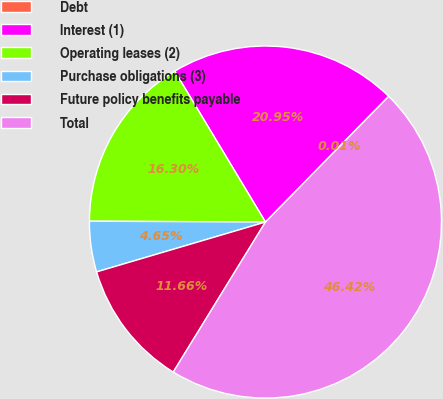Convert chart. <chart><loc_0><loc_0><loc_500><loc_500><pie_chart><fcel>Debt<fcel>Interest (1)<fcel>Operating leases (2)<fcel>Purchase obligations (3)<fcel>Future policy benefits payable<fcel>Total<nl><fcel>0.01%<fcel>20.95%<fcel>16.3%<fcel>4.65%<fcel>11.66%<fcel>46.42%<nl></chart> 